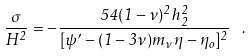Convert formula to latex. <formula><loc_0><loc_0><loc_500><loc_500>\frac { \sigma } { H ^ { 2 } } = - \frac { 5 4 ( 1 - \nu ) ^ { 2 } h _ { 2 } ^ { 2 } } { [ \psi ^ { \prime } - ( 1 - 3 \nu ) m _ { \nu } \eta - \eta _ { o } ] ^ { 2 } } \, \ .</formula> 